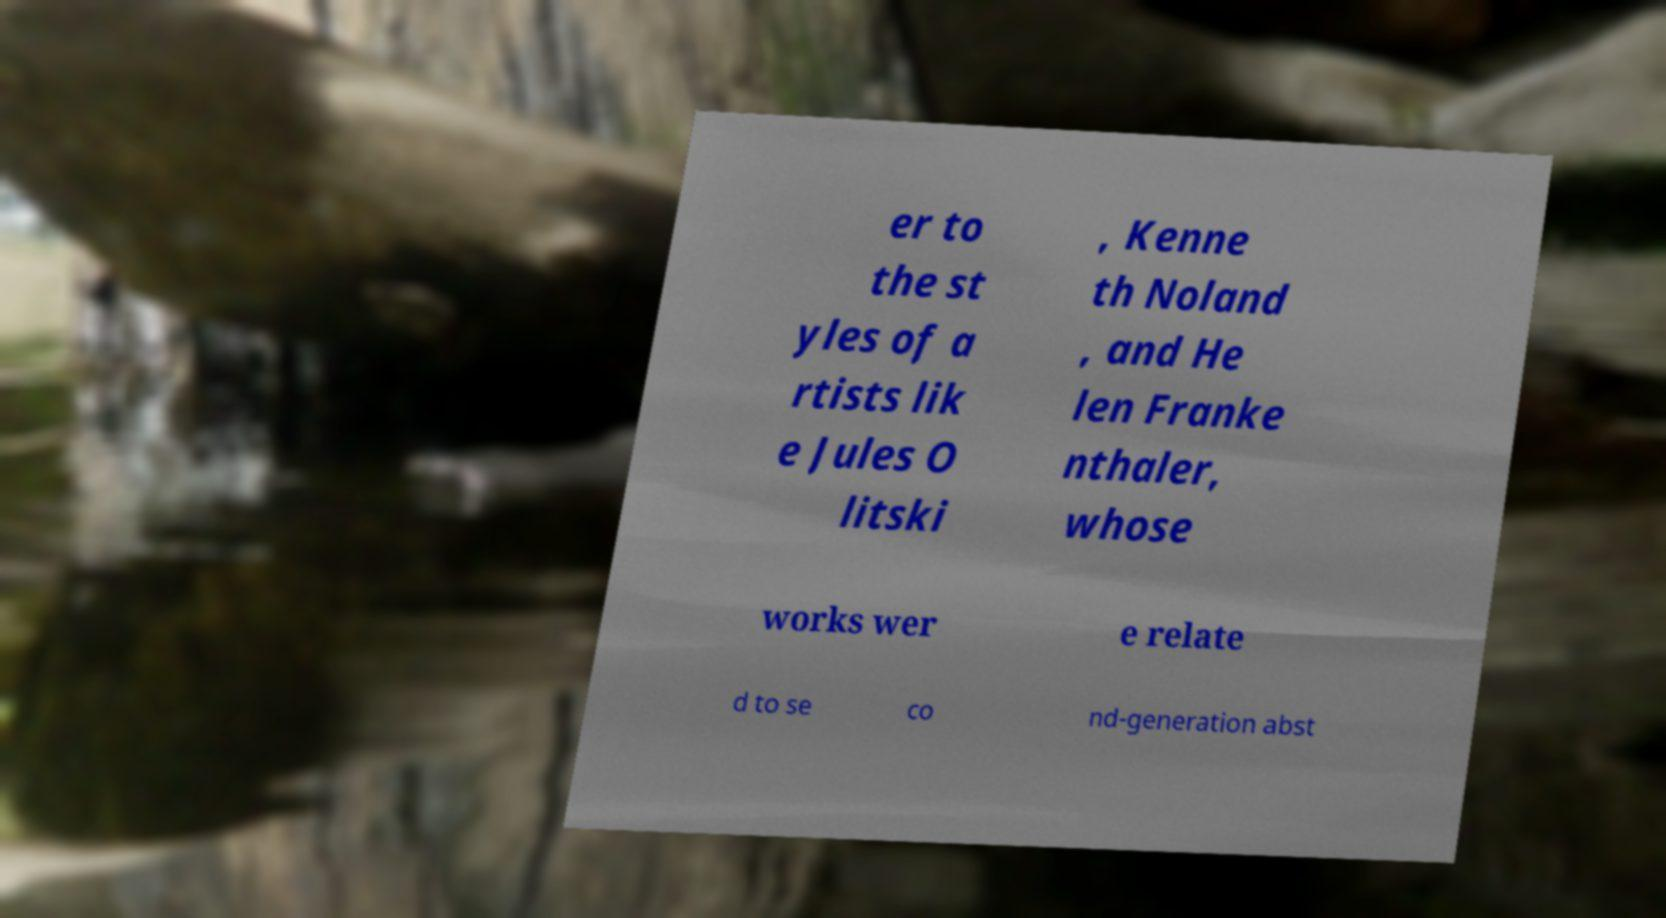Can you accurately transcribe the text from the provided image for me? er to the st yles of a rtists lik e Jules O litski , Kenne th Noland , and He len Franke nthaler, whose works wer e relate d to se co nd-generation abst 